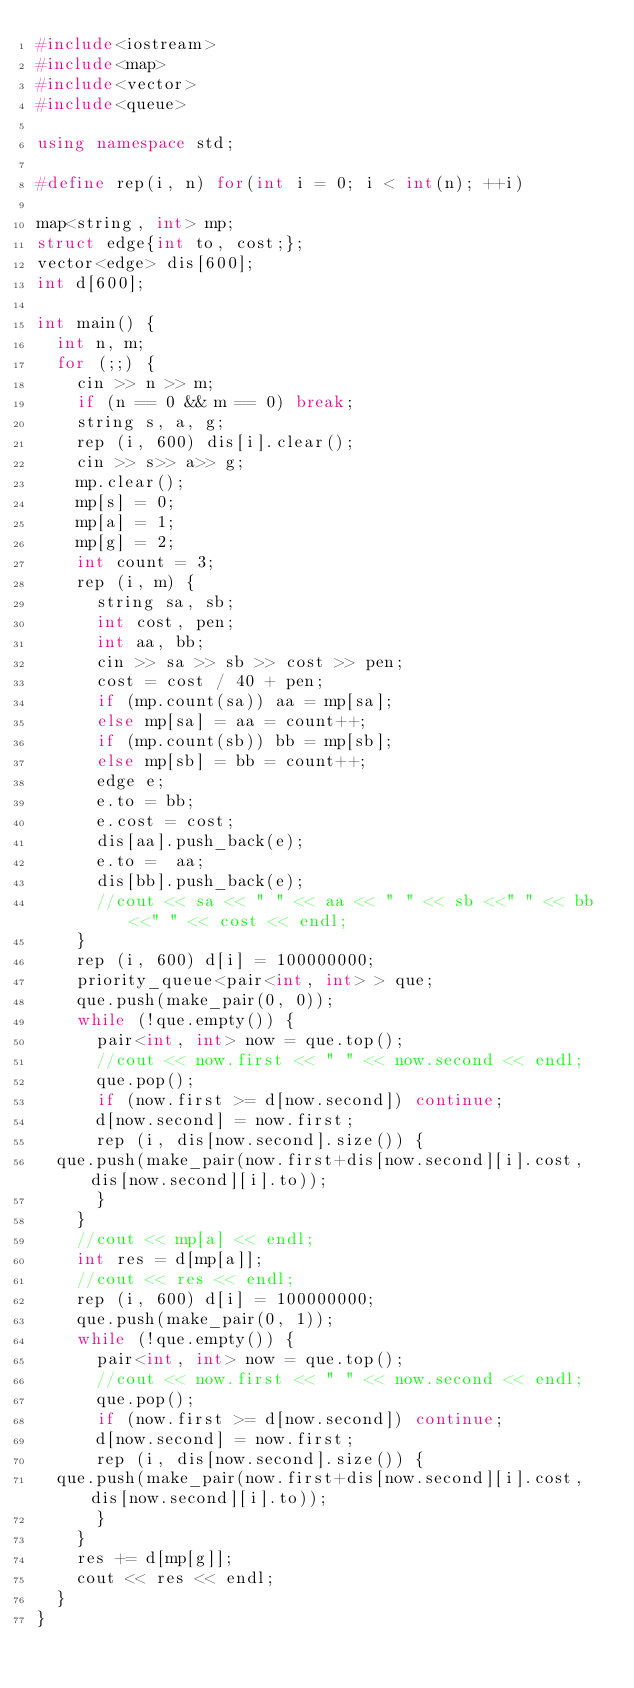<code> <loc_0><loc_0><loc_500><loc_500><_C++_>#include<iostream>
#include<map>
#include<vector>
#include<queue>

using namespace std;

#define rep(i, n) for(int i = 0; i < int(n); ++i)

map<string, int> mp;
struct edge{int to, cost;};
vector<edge> dis[600];
int d[600];

int main() {
  int n, m;
  for (;;) {
    cin >> n >> m;
    if (n == 0 && m == 0) break;
    string s, a, g;
    rep (i, 600) dis[i].clear();
    cin >> s>> a>> g;
    mp.clear();
    mp[s] = 0;
    mp[a] = 1;
    mp[g] = 2;
    int count = 3;
    rep (i, m) {
      string sa, sb;
      int cost, pen;
      int aa, bb;
      cin >> sa >> sb >> cost >> pen;
      cost = cost / 40 + pen;
      if (mp.count(sa)) aa = mp[sa];
      else mp[sa] = aa = count++;
      if (mp.count(sb)) bb = mp[sb];
      else mp[sb] = bb = count++;
      edge e;
      e.to = bb;
      e.cost = cost;
      dis[aa].push_back(e);
      e.to =  aa;
      dis[bb].push_back(e);
      //cout << sa << " " << aa << " " << sb <<" " << bb <<" " << cost << endl;
    }
    rep (i, 600) d[i] = 100000000;
    priority_queue<pair<int, int> > que;
    que.push(make_pair(0, 0));
    while (!que.empty()) {
      pair<int, int> now = que.top();
      //cout << now.first << " " << now.second << endl;
      que.pop();
      if (now.first >= d[now.second]) continue;
      d[now.second] = now.first;
      rep (i, dis[now.second].size()) {
	que.push(make_pair(now.first+dis[now.second][i].cost, dis[now.second][i].to));
      }
    }
    //cout << mp[a] << endl;
    int res = d[mp[a]];
    //cout << res << endl;
    rep (i, 600) d[i] = 100000000;
    que.push(make_pair(0, 1));
    while (!que.empty()) {
      pair<int, int> now = que.top();
      //cout << now.first << " " << now.second << endl;
      que.pop();
      if (now.first >= d[now.second]) continue;
      d[now.second] = now.first;
      rep (i, dis[now.second].size()) {
	que.push(make_pair(now.first+dis[now.second][i].cost, dis[now.second][i].to));
      }
    }
    res += d[mp[g]];
    cout << res << endl;
  }
}</code> 